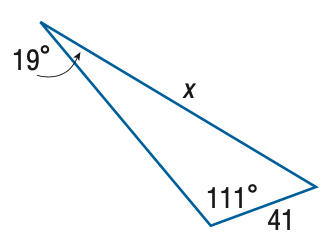Question: Find x. Round the side measure to the nearest tenth.
Choices:
A. 14.3
B. 17.4
C. 96.5
D. 117.6
Answer with the letter. Answer: D 